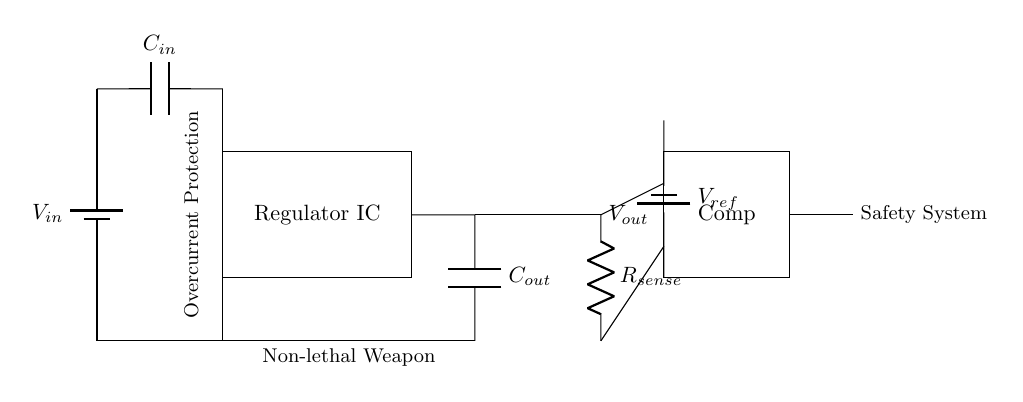What is the function of the regulator IC? The regulator IC in the circuit converts the input voltage to a stable output voltage while providing overcurrent protection. This is indicated by its position and purpose in the circuit.
Answer: voltage regulation What component provides the output capacitance? The output capacitor, denoted as Cout, is responsible for smoothing the output voltage and is positioned between the regulator and the ground. Its label in the diagram identifies it clearly.
Answer: Cout What is the reference voltage in the circuit? The reference voltage is indicated by Vref and is provided by a battery located connected to the comparator. This reference voltage is crucial for determining the threshold for overcurrent protection.
Answer: Vref What is the purpose of the current sense resistor? The current sense resistor, labeled Rsense, is used to measure the current flowing through the circuit. This measurement is necessary to detect if the current exceeds a specified limit, triggering the overcurrent protection mechanism.
Answer: current measurement When does the comparator trigger the safety system? The comparator compares the voltage across the current sense resistor with the reference voltage. If the sensed current (converted to voltage) exceeds Vref, the comparator activates the safety system. This logic is based on the fundamental function of a comparator in controlling circuit output based on input voltages.
Answer: when current exceeds Vref What happens to the circuit if an overcurrent is detected? If an overcurrent condition is detected, the comparator will signal the safety system to take action to disable or limit the current, thereby protecting the overall system from damage. This is the designed response of the system to maintain safety.
Answer: system protection 